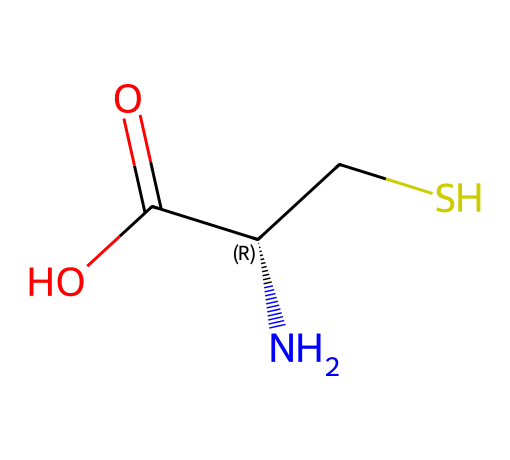what is the name of this compound? The SMILES representation provided corresponds to the amino acid cysteine, which includes sulfur in its structure. The presence of the "CS" portion indicates the sulfur atom bonded to a carbon atom, characteristic of cysteine.
Answer: cysteine how many carbon atoms are in cysteine? Analyzing the SMILES, there are two carbon atoms in cysteine: one from the "C" before the "S" and another from the "C" in the carboxylic acid group "C(=O)O".
Answer: two how many nitrogen atoms does this compound contain? The SMILES shows "N" at the beginning, indicating the presence of one nitrogen atom in cysteine. Counting this single "N" provides the answer.
Answer: one what type of functional group is present in cysteine? The SMILES representation includes "C(=O)O," indicating a carboxylic acid functional group, which is a defining feature of all amino acids, including cysteine.
Answer: carboxylic acid which element in cysteine is responsible for its unique properties compared to other amino acids? The presence of sulfur (indicated by "S" in the SMILES) is unique among standard amino acids and influences the properties of cysteine, such as the formation of disulfide bonds in protein structures.
Answer: sulfur what is the total number of hydrogen atoms in cysteine? To find the number of hydrogen atoms, count the implicit hydrogens around the carbon and nitrogen in the structure. Cysteine has 7 hydrogen atoms represented implicitly in the structure.
Answer: seven what role does the sulfur atom play in protein structure related to cysteine? The sulfur atom in cysteine can form disulfide bridges or bonds when cysteine residues are close together in a protein. This bonding is crucial for maintaining protein structure and stability.
Answer: disulfide bridges 